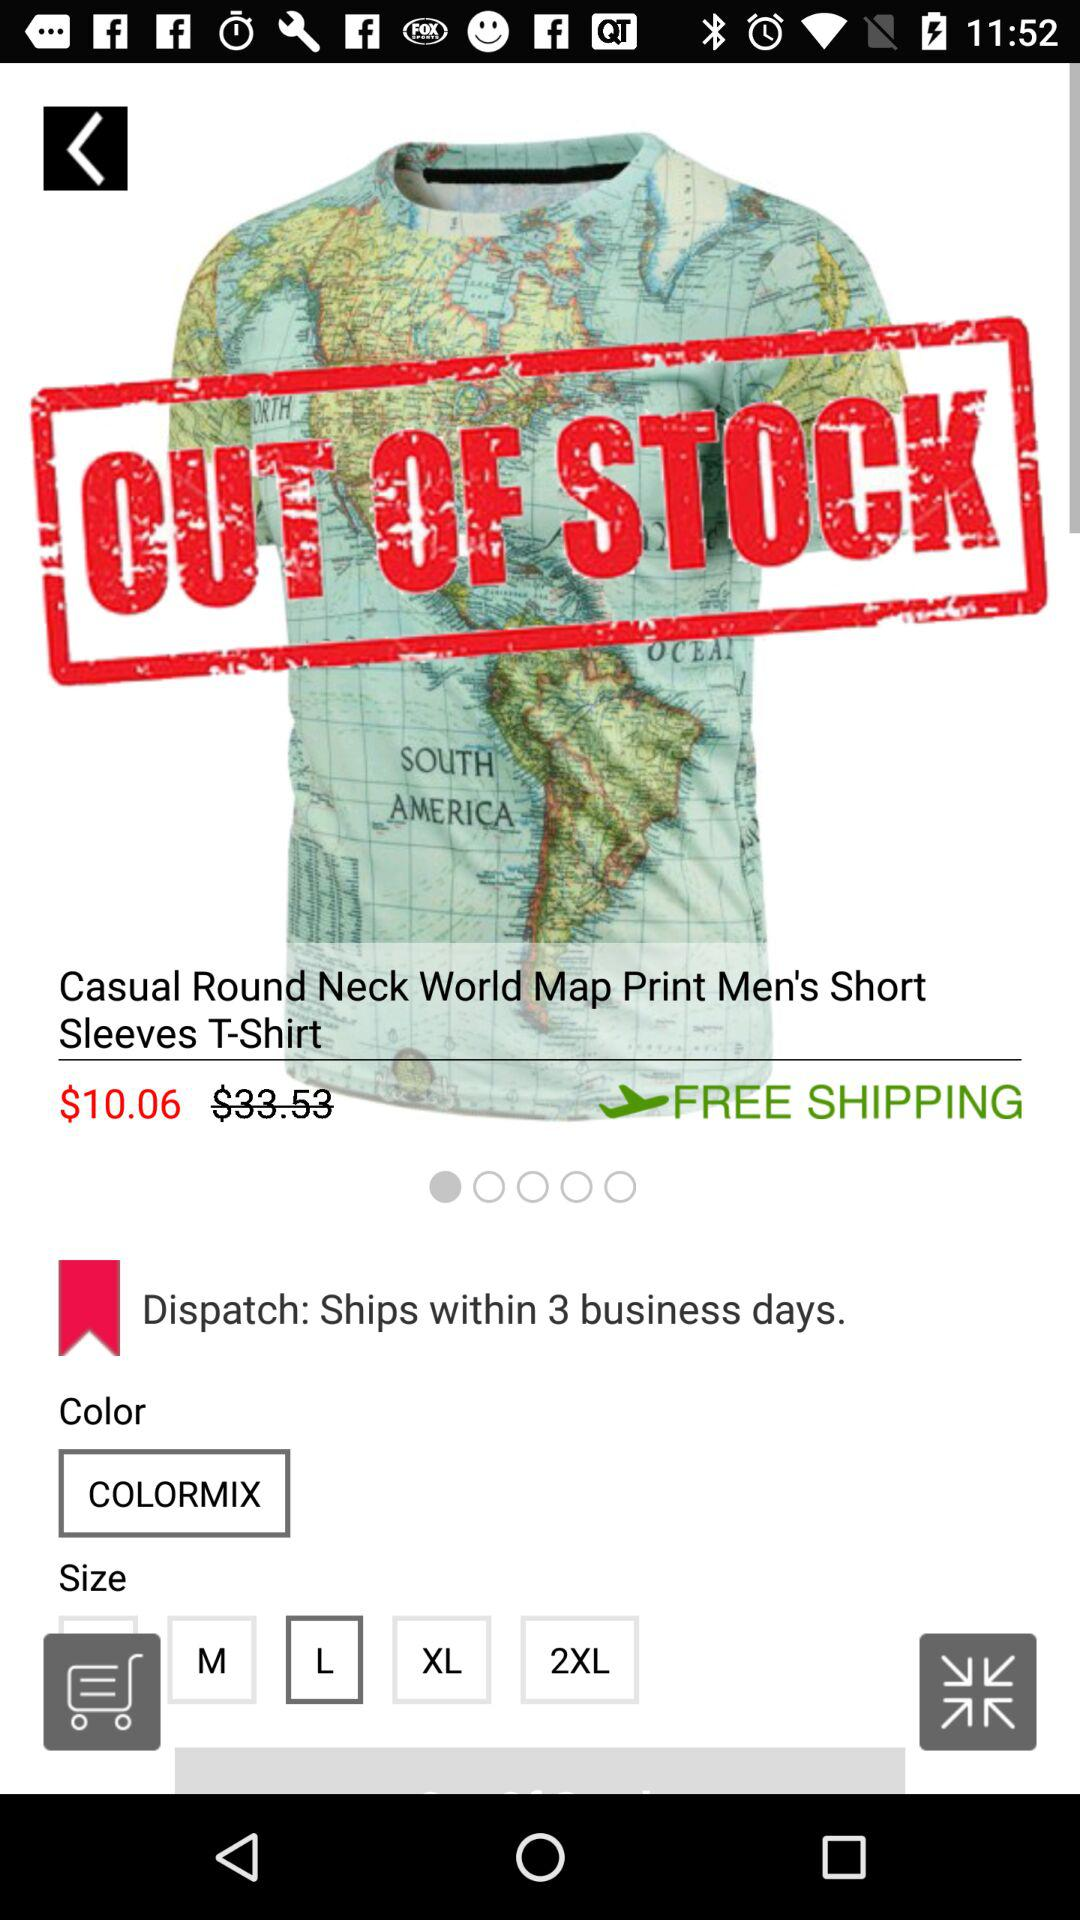What is the given price? The given price is $10.06. 